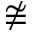<formula> <loc_0><loc_0><loc_500><loc_500>\ncong</formula> 